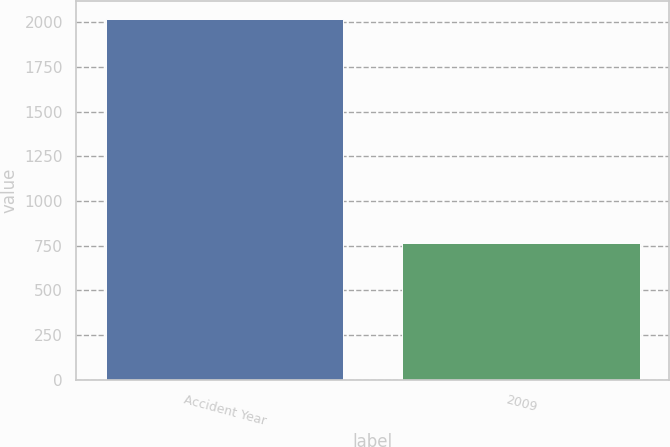Convert chart to OTSL. <chart><loc_0><loc_0><loc_500><loc_500><bar_chart><fcel>Accident Year<fcel>2009<nl><fcel>2018<fcel>767<nl></chart> 